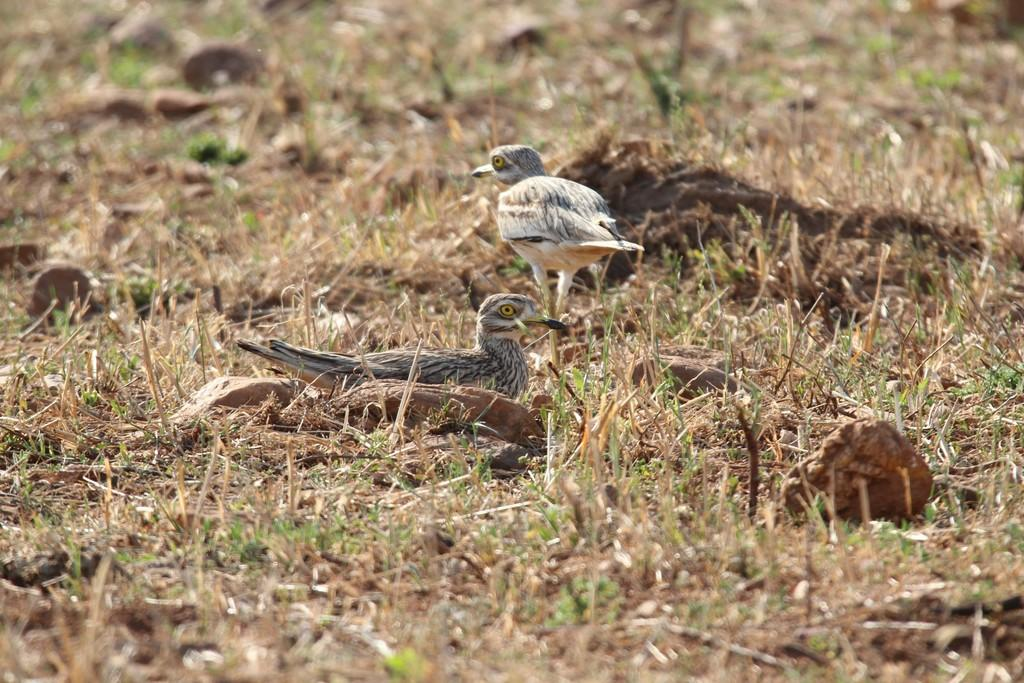What type of animals are on the ground in the image? There are birds on the ground in the image. What type of natural elements can be seen in the image? Rocks and grass are visible in the image. What type of expansion can be seen in the image? There is no expansion visible in the image; it is a still image of birds, rocks, and grass. 